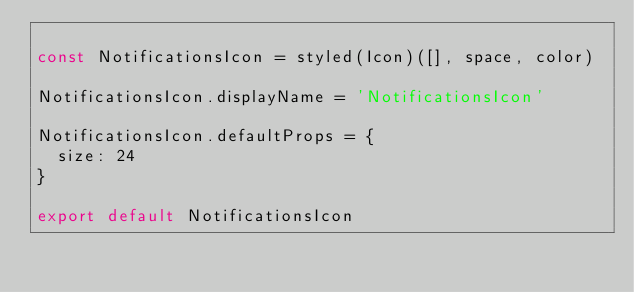<code> <loc_0><loc_0><loc_500><loc_500><_JavaScript_>
const NotificationsIcon = styled(Icon)([], space, color)

NotificationsIcon.displayName = 'NotificationsIcon'

NotificationsIcon.defaultProps = {
  size: 24
}

export default NotificationsIcon</code> 